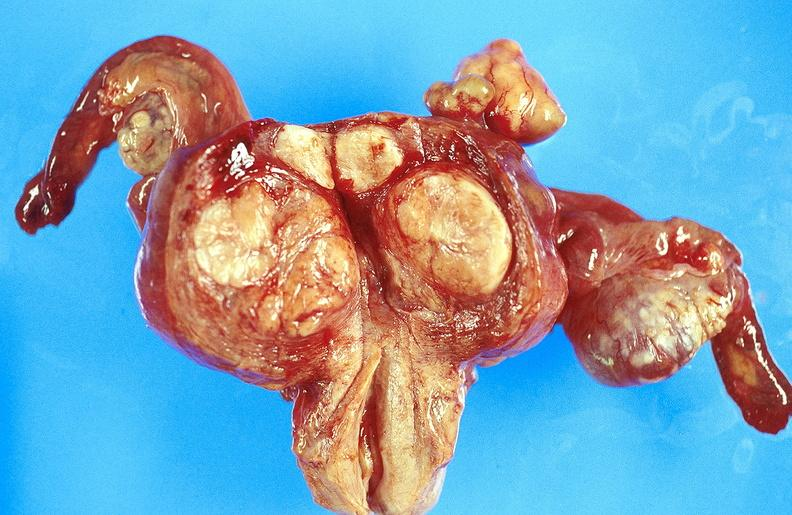does this image show uterus, leiomyoma?
Answer the question using a single word or phrase. Yes 